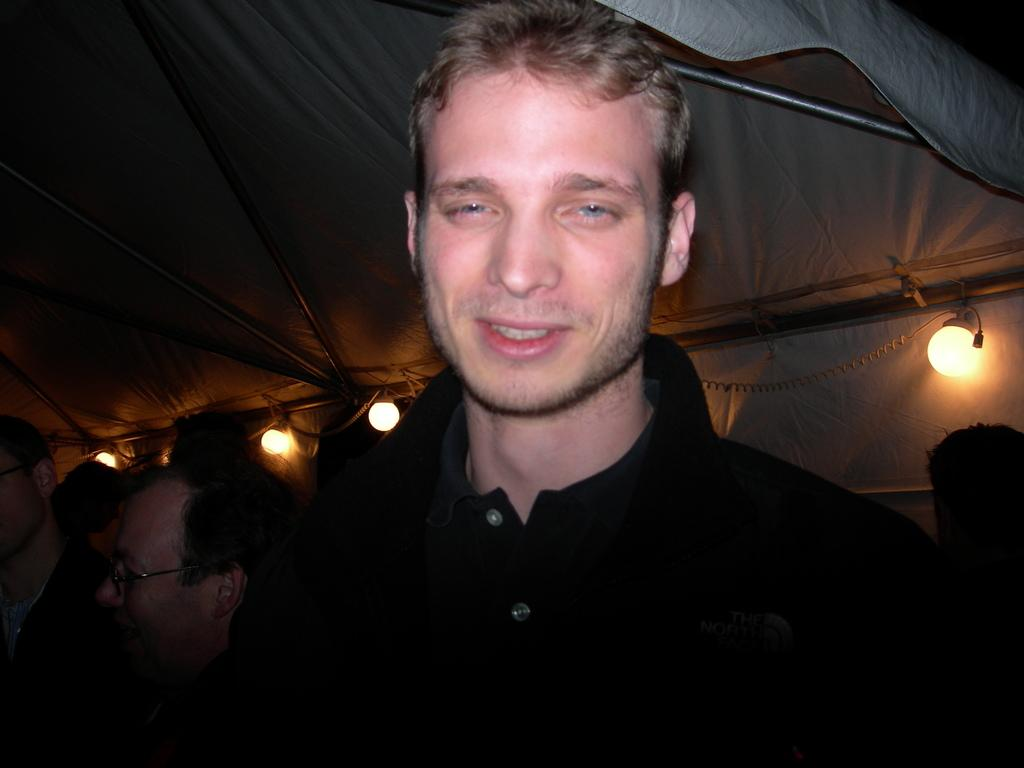Who is the main subject in the image? There is a man in the center of the image. What is the man wearing? The man is wearing a black t-shirt. Where is the man located in the image? The man is under a tent. Are there any other people visible in the image? Yes, there are other persons visible behind the man. What can be seen in the image that provides illumination? Lights are present in the image. What type of horse is depicted in the verse on the man's t-shirt? There is no horse or verse present on the man's t-shirt in the image. What type of office furniture can be seen in the image? There is no office furniture present in the image. 